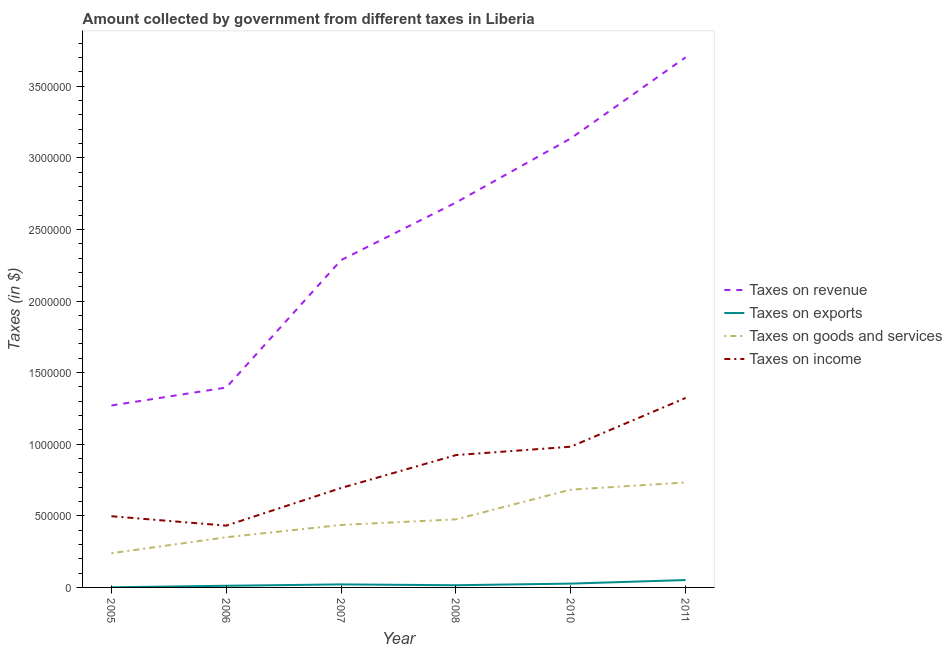What is the amount collected as tax on revenue in 2011?
Offer a terse response. 3.70e+06. Across all years, what is the maximum amount collected as tax on revenue?
Make the answer very short. 3.70e+06. Across all years, what is the minimum amount collected as tax on exports?
Your answer should be very brief. 822.63. What is the total amount collected as tax on income in the graph?
Offer a terse response. 4.85e+06. What is the difference between the amount collected as tax on income in 2007 and that in 2010?
Your answer should be compact. -2.88e+05. What is the difference between the amount collected as tax on exports in 2011 and the amount collected as tax on income in 2008?
Provide a short and direct response. -8.73e+05. What is the average amount collected as tax on revenue per year?
Your response must be concise. 2.41e+06. In the year 2008, what is the difference between the amount collected as tax on income and amount collected as tax on revenue?
Ensure brevity in your answer.  -1.76e+06. In how many years, is the amount collected as tax on goods greater than 2000000 $?
Offer a very short reply. 0. What is the ratio of the amount collected as tax on income in 2005 to that in 2008?
Give a very brief answer. 0.54. Is the amount collected as tax on exports in 2006 less than that in 2008?
Give a very brief answer. Yes. What is the difference between the highest and the second highest amount collected as tax on income?
Keep it short and to the point. 3.41e+05. What is the difference between the highest and the lowest amount collected as tax on income?
Provide a short and direct response. 8.92e+05. In how many years, is the amount collected as tax on exports greater than the average amount collected as tax on exports taken over all years?
Your answer should be compact. 2. Is it the case that in every year, the sum of the amount collected as tax on goods and amount collected as tax on income is greater than the sum of amount collected as tax on exports and amount collected as tax on revenue?
Offer a very short reply. No. Is it the case that in every year, the sum of the amount collected as tax on revenue and amount collected as tax on exports is greater than the amount collected as tax on goods?
Your answer should be compact. Yes. How many years are there in the graph?
Your answer should be compact. 6. What is the difference between two consecutive major ticks on the Y-axis?
Your answer should be compact. 5.00e+05. Does the graph contain any zero values?
Offer a very short reply. No. Does the graph contain grids?
Provide a short and direct response. No. Where does the legend appear in the graph?
Make the answer very short. Center right. How many legend labels are there?
Your answer should be very brief. 4. What is the title of the graph?
Make the answer very short. Amount collected by government from different taxes in Liberia. Does "UNHCR" appear as one of the legend labels in the graph?
Make the answer very short. No. What is the label or title of the X-axis?
Make the answer very short. Year. What is the label or title of the Y-axis?
Ensure brevity in your answer.  Taxes (in $). What is the Taxes (in $) in Taxes on revenue in 2005?
Your answer should be compact. 1.27e+06. What is the Taxes (in $) of Taxes on exports in 2005?
Keep it short and to the point. 822.63. What is the Taxes (in $) of Taxes on goods and services in 2005?
Offer a terse response. 2.39e+05. What is the Taxes (in $) of Taxes on income in 2005?
Provide a short and direct response. 4.97e+05. What is the Taxes (in $) in Taxes on revenue in 2006?
Ensure brevity in your answer.  1.40e+06. What is the Taxes (in $) of Taxes on exports in 2006?
Keep it short and to the point. 1.16e+04. What is the Taxes (in $) in Taxes on goods and services in 2006?
Your answer should be very brief. 3.50e+05. What is the Taxes (in $) in Taxes on income in 2006?
Keep it short and to the point. 4.32e+05. What is the Taxes (in $) in Taxes on revenue in 2007?
Your answer should be very brief. 2.29e+06. What is the Taxes (in $) of Taxes on exports in 2007?
Offer a terse response. 2.11e+04. What is the Taxes (in $) of Taxes on goods and services in 2007?
Offer a terse response. 4.36e+05. What is the Taxes (in $) of Taxes on income in 2007?
Provide a short and direct response. 6.94e+05. What is the Taxes (in $) in Taxes on revenue in 2008?
Give a very brief answer. 2.69e+06. What is the Taxes (in $) in Taxes on exports in 2008?
Your response must be concise. 1.54e+04. What is the Taxes (in $) of Taxes on goods and services in 2008?
Provide a short and direct response. 4.75e+05. What is the Taxes (in $) in Taxes on income in 2008?
Keep it short and to the point. 9.24e+05. What is the Taxes (in $) of Taxes on revenue in 2010?
Offer a terse response. 3.14e+06. What is the Taxes (in $) of Taxes on exports in 2010?
Give a very brief answer. 2.67e+04. What is the Taxes (in $) of Taxes on goods and services in 2010?
Offer a very short reply. 6.83e+05. What is the Taxes (in $) in Taxes on income in 2010?
Provide a succinct answer. 9.83e+05. What is the Taxes (in $) of Taxes on revenue in 2011?
Offer a terse response. 3.70e+06. What is the Taxes (in $) of Taxes on exports in 2011?
Provide a short and direct response. 5.15e+04. What is the Taxes (in $) in Taxes on goods and services in 2011?
Your answer should be very brief. 7.33e+05. What is the Taxes (in $) of Taxes on income in 2011?
Ensure brevity in your answer.  1.32e+06. Across all years, what is the maximum Taxes (in $) of Taxes on revenue?
Your answer should be compact. 3.70e+06. Across all years, what is the maximum Taxes (in $) of Taxes on exports?
Offer a very short reply. 5.15e+04. Across all years, what is the maximum Taxes (in $) of Taxes on goods and services?
Your answer should be very brief. 7.33e+05. Across all years, what is the maximum Taxes (in $) of Taxes on income?
Your answer should be very brief. 1.32e+06. Across all years, what is the minimum Taxes (in $) in Taxes on revenue?
Offer a terse response. 1.27e+06. Across all years, what is the minimum Taxes (in $) in Taxes on exports?
Provide a succinct answer. 822.63. Across all years, what is the minimum Taxes (in $) in Taxes on goods and services?
Ensure brevity in your answer.  2.39e+05. Across all years, what is the minimum Taxes (in $) of Taxes on income?
Offer a terse response. 4.32e+05. What is the total Taxes (in $) in Taxes on revenue in the graph?
Your answer should be very brief. 1.45e+07. What is the total Taxes (in $) of Taxes on exports in the graph?
Offer a very short reply. 1.27e+05. What is the total Taxes (in $) of Taxes on goods and services in the graph?
Your response must be concise. 2.92e+06. What is the total Taxes (in $) in Taxes on income in the graph?
Your answer should be very brief. 4.85e+06. What is the difference between the Taxes (in $) of Taxes on revenue in 2005 and that in 2006?
Ensure brevity in your answer.  -1.25e+05. What is the difference between the Taxes (in $) in Taxes on exports in 2005 and that in 2006?
Your answer should be very brief. -1.08e+04. What is the difference between the Taxes (in $) in Taxes on goods and services in 2005 and that in 2006?
Your answer should be compact. -1.11e+05. What is the difference between the Taxes (in $) in Taxes on income in 2005 and that in 2006?
Offer a terse response. 6.55e+04. What is the difference between the Taxes (in $) in Taxes on revenue in 2005 and that in 2007?
Your answer should be compact. -1.02e+06. What is the difference between the Taxes (in $) in Taxes on exports in 2005 and that in 2007?
Ensure brevity in your answer.  -2.03e+04. What is the difference between the Taxes (in $) in Taxes on goods and services in 2005 and that in 2007?
Keep it short and to the point. -1.97e+05. What is the difference between the Taxes (in $) of Taxes on income in 2005 and that in 2007?
Give a very brief answer. -1.97e+05. What is the difference between the Taxes (in $) in Taxes on revenue in 2005 and that in 2008?
Your response must be concise. -1.42e+06. What is the difference between the Taxes (in $) of Taxes on exports in 2005 and that in 2008?
Your answer should be compact. -1.45e+04. What is the difference between the Taxes (in $) of Taxes on goods and services in 2005 and that in 2008?
Ensure brevity in your answer.  -2.36e+05. What is the difference between the Taxes (in $) in Taxes on income in 2005 and that in 2008?
Your response must be concise. -4.27e+05. What is the difference between the Taxes (in $) in Taxes on revenue in 2005 and that in 2010?
Your response must be concise. -1.87e+06. What is the difference between the Taxes (in $) of Taxes on exports in 2005 and that in 2010?
Provide a short and direct response. -2.58e+04. What is the difference between the Taxes (in $) in Taxes on goods and services in 2005 and that in 2010?
Give a very brief answer. -4.44e+05. What is the difference between the Taxes (in $) of Taxes on income in 2005 and that in 2010?
Offer a terse response. -4.86e+05. What is the difference between the Taxes (in $) of Taxes on revenue in 2005 and that in 2011?
Keep it short and to the point. -2.43e+06. What is the difference between the Taxes (in $) in Taxes on exports in 2005 and that in 2011?
Offer a very short reply. -5.07e+04. What is the difference between the Taxes (in $) in Taxes on goods and services in 2005 and that in 2011?
Offer a very short reply. -4.94e+05. What is the difference between the Taxes (in $) in Taxes on income in 2005 and that in 2011?
Ensure brevity in your answer.  -8.26e+05. What is the difference between the Taxes (in $) of Taxes on revenue in 2006 and that in 2007?
Offer a terse response. -8.90e+05. What is the difference between the Taxes (in $) in Taxes on exports in 2006 and that in 2007?
Offer a very short reply. -9442.48. What is the difference between the Taxes (in $) of Taxes on goods and services in 2006 and that in 2007?
Ensure brevity in your answer.  -8.60e+04. What is the difference between the Taxes (in $) of Taxes on income in 2006 and that in 2007?
Give a very brief answer. -2.63e+05. What is the difference between the Taxes (in $) of Taxes on revenue in 2006 and that in 2008?
Make the answer very short. -1.29e+06. What is the difference between the Taxes (in $) of Taxes on exports in 2006 and that in 2008?
Give a very brief answer. -3711.06. What is the difference between the Taxes (in $) of Taxes on goods and services in 2006 and that in 2008?
Ensure brevity in your answer.  -1.25e+05. What is the difference between the Taxes (in $) in Taxes on income in 2006 and that in 2008?
Offer a terse response. -4.93e+05. What is the difference between the Taxes (in $) in Taxes on revenue in 2006 and that in 2010?
Provide a succinct answer. -1.74e+06. What is the difference between the Taxes (in $) of Taxes on exports in 2006 and that in 2010?
Offer a very short reply. -1.50e+04. What is the difference between the Taxes (in $) of Taxes on goods and services in 2006 and that in 2010?
Your answer should be very brief. -3.32e+05. What is the difference between the Taxes (in $) in Taxes on income in 2006 and that in 2010?
Ensure brevity in your answer.  -5.51e+05. What is the difference between the Taxes (in $) of Taxes on revenue in 2006 and that in 2011?
Provide a succinct answer. -2.31e+06. What is the difference between the Taxes (in $) in Taxes on exports in 2006 and that in 2011?
Offer a very short reply. -3.99e+04. What is the difference between the Taxes (in $) of Taxes on goods and services in 2006 and that in 2011?
Provide a succinct answer. -3.83e+05. What is the difference between the Taxes (in $) of Taxes on income in 2006 and that in 2011?
Your answer should be very brief. -8.92e+05. What is the difference between the Taxes (in $) of Taxes on revenue in 2007 and that in 2008?
Give a very brief answer. -4.02e+05. What is the difference between the Taxes (in $) of Taxes on exports in 2007 and that in 2008?
Offer a terse response. 5731.42. What is the difference between the Taxes (in $) of Taxes on goods and services in 2007 and that in 2008?
Make the answer very short. -3.91e+04. What is the difference between the Taxes (in $) of Taxes on income in 2007 and that in 2008?
Your response must be concise. -2.30e+05. What is the difference between the Taxes (in $) of Taxes on revenue in 2007 and that in 2010?
Ensure brevity in your answer.  -8.50e+05. What is the difference between the Taxes (in $) in Taxes on exports in 2007 and that in 2010?
Keep it short and to the point. -5566.22. What is the difference between the Taxes (in $) in Taxes on goods and services in 2007 and that in 2010?
Your response must be concise. -2.46e+05. What is the difference between the Taxes (in $) in Taxes on income in 2007 and that in 2010?
Make the answer very short. -2.88e+05. What is the difference between the Taxes (in $) of Taxes on revenue in 2007 and that in 2011?
Offer a terse response. -1.42e+06. What is the difference between the Taxes (in $) of Taxes on exports in 2007 and that in 2011?
Keep it short and to the point. -3.05e+04. What is the difference between the Taxes (in $) of Taxes on goods and services in 2007 and that in 2011?
Provide a short and direct response. -2.97e+05. What is the difference between the Taxes (in $) of Taxes on income in 2007 and that in 2011?
Your answer should be very brief. -6.29e+05. What is the difference between the Taxes (in $) of Taxes on revenue in 2008 and that in 2010?
Your answer should be compact. -4.48e+05. What is the difference between the Taxes (in $) of Taxes on exports in 2008 and that in 2010?
Ensure brevity in your answer.  -1.13e+04. What is the difference between the Taxes (in $) of Taxes on goods and services in 2008 and that in 2010?
Keep it short and to the point. -2.07e+05. What is the difference between the Taxes (in $) in Taxes on income in 2008 and that in 2010?
Offer a terse response. -5.85e+04. What is the difference between the Taxes (in $) of Taxes on revenue in 2008 and that in 2011?
Provide a short and direct response. -1.01e+06. What is the difference between the Taxes (in $) in Taxes on exports in 2008 and that in 2011?
Offer a terse response. -3.62e+04. What is the difference between the Taxes (in $) in Taxes on goods and services in 2008 and that in 2011?
Make the answer very short. -2.58e+05. What is the difference between the Taxes (in $) in Taxes on income in 2008 and that in 2011?
Offer a very short reply. -3.99e+05. What is the difference between the Taxes (in $) of Taxes on revenue in 2010 and that in 2011?
Provide a short and direct response. -5.66e+05. What is the difference between the Taxes (in $) of Taxes on exports in 2010 and that in 2011?
Provide a succinct answer. -2.49e+04. What is the difference between the Taxes (in $) of Taxes on goods and services in 2010 and that in 2011?
Your response must be concise. -5.03e+04. What is the difference between the Taxes (in $) of Taxes on income in 2010 and that in 2011?
Offer a terse response. -3.41e+05. What is the difference between the Taxes (in $) in Taxes on revenue in 2005 and the Taxes (in $) in Taxes on exports in 2006?
Provide a succinct answer. 1.26e+06. What is the difference between the Taxes (in $) in Taxes on revenue in 2005 and the Taxes (in $) in Taxes on goods and services in 2006?
Provide a short and direct response. 9.20e+05. What is the difference between the Taxes (in $) of Taxes on revenue in 2005 and the Taxes (in $) of Taxes on income in 2006?
Your response must be concise. 8.39e+05. What is the difference between the Taxes (in $) of Taxes on exports in 2005 and the Taxes (in $) of Taxes on goods and services in 2006?
Provide a succinct answer. -3.49e+05. What is the difference between the Taxes (in $) of Taxes on exports in 2005 and the Taxes (in $) of Taxes on income in 2006?
Your answer should be compact. -4.31e+05. What is the difference between the Taxes (in $) of Taxes on goods and services in 2005 and the Taxes (in $) of Taxes on income in 2006?
Provide a short and direct response. -1.92e+05. What is the difference between the Taxes (in $) in Taxes on revenue in 2005 and the Taxes (in $) in Taxes on exports in 2007?
Provide a short and direct response. 1.25e+06. What is the difference between the Taxes (in $) of Taxes on revenue in 2005 and the Taxes (in $) of Taxes on goods and services in 2007?
Provide a short and direct response. 8.34e+05. What is the difference between the Taxes (in $) of Taxes on revenue in 2005 and the Taxes (in $) of Taxes on income in 2007?
Give a very brief answer. 5.76e+05. What is the difference between the Taxes (in $) of Taxes on exports in 2005 and the Taxes (in $) of Taxes on goods and services in 2007?
Keep it short and to the point. -4.35e+05. What is the difference between the Taxes (in $) of Taxes on exports in 2005 and the Taxes (in $) of Taxes on income in 2007?
Keep it short and to the point. -6.93e+05. What is the difference between the Taxes (in $) of Taxes on goods and services in 2005 and the Taxes (in $) of Taxes on income in 2007?
Give a very brief answer. -4.55e+05. What is the difference between the Taxes (in $) of Taxes on revenue in 2005 and the Taxes (in $) of Taxes on exports in 2008?
Make the answer very short. 1.25e+06. What is the difference between the Taxes (in $) of Taxes on revenue in 2005 and the Taxes (in $) of Taxes on goods and services in 2008?
Make the answer very short. 7.95e+05. What is the difference between the Taxes (in $) in Taxes on revenue in 2005 and the Taxes (in $) in Taxes on income in 2008?
Your response must be concise. 3.46e+05. What is the difference between the Taxes (in $) of Taxes on exports in 2005 and the Taxes (in $) of Taxes on goods and services in 2008?
Make the answer very short. -4.75e+05. What is the difference between the Taxes (in $) of Taxes on exports in 2005 and the Taxes (in $) of Taxes on income in 2008?
Your response must be concise. -9.23e+05. What is the difference between the Taxes (in $) in Taxes on goods and services in 2005 and the Taxes (in $) in Taxes on income in 2008?
Give a very brief answer. -6.85e+05. What is the difference between the Taxes (in $) in Taxes on revenue in 2005 and the Taxes (in $) in Taxes on exports in 2010?
Give a very brief answer. 1.24e+06. What is the difference between the Taxes (in $) of Taxes on revenue in 2005 and the Taxes (in $) of Taxes on goods and services in 2010?
Provide a succinct answer. 5.88e+05. What is the difference between the Taxes (in $) of Taxes on revenue in 2005 and the Taxes (in $) of Taxes on income in 2010?
Offer a very short reply. 2.88e+05. What is the difference between the Taxes (in $) of Taxes on exports in 2005 and the Taxes (in $) of Taxes on goods and services in 2010?
Provide a succinct answer. -6.82e+05. What is the difference between the Taxes (in $) in Taxes on exports in 2005 and the Taxes (in $) in Taxes on income in 2010?
Your answer should be very brief. -9.82e+05. What is the difference between the Taxes (in $) of Taxes on goods and services in 2005 and the Taxes (in $) of Taxes on income in 2010?
Offer a very short reply. -7.43e+05. What is the difference between the Taxes (in $) of Taxes on revenue in 2005 and the Taxes (in $) of Taxes on exports in 2011?
Your response must be concise. 1.22e+06. What is the difference between the Taxes (in $) in Taxes on revenue in 2005 and the Taxes (in $) in Taxes on goods and services in 2011?
Keep it short and to the point. 5.37e+05. What is the difference between the Taxes (in $) in Taxes on revenue in 2005 and the Taxes (in $) in Taxes on income in 2011?
Give a very brief answer. -5.28e+04. What is the difference between the Taxes (in $) of Taxes on exports in 2005 and the Taxes (in $) of Taxes on goods and services in 2011?
Your response must be concise. -7.32e+05. What is the difference between the Taxes (in $) of Taxes on exports in 2005 and the Taxes (in $) of Taxes on income in 2011?
Keep it short and to the point. -1.32e+06. What is the difference between the Taxes (in $) in Taxes on goods and services in 2005 and the Taxes (in $) in Taxes on income in 2011?
Provide a succinct answer. -1.08e+06. What is the difference between the Taxes (in $) of Taxes on revenue in 2006 and the Taxes (in $) of Taxes on exports in 2007?
Provide a short and direct response. 1.37e+06. What is the difference between the Taxes (in $) of Taxes on revenue in 2006 and the Taxes (in $) of Taxes on goods and services in 2007?
Make the answer very short. 9.60e+05. What is the difference between the Taxes (in $) in Taxes on revenue in 2006 and the Taxes (in $) in Taxes on income in 2007?
Offer a terse response. 7.01e+05. What is the difference between the Taxes (in $) in Taxes on exports in 2006 and the Taxes (in $) in Taxes on goods and services in 2007?
Provide a short and direct response. -4.25e+05. What is the difference between the Taxes (in $) in Taxes on exports in 2006 and the Taxes (in $) in Taxes on income in 2007?
Your answer should be very brief. -6.83e+05. What is the difference between the Taxes (in $) in Taxes on goods and services in 2006 and the Taxes (in $) in Taxes on income in 2007?
Provide a short and direct response. -3.44e+05. What is the difference between the Taxes (in $) of Taxes on revenue in 2006 and the Taxes (in $) of Taxes on exports in 2008?
Keep it short and to the point. 1.38e+06. What is the difference between the Taxes (in $) in Taxes on revenue in 2006 and the Taxes (in $) in Taxes on goods and services in 2008?
Your answer should be compact. 9.20e+05. What is the difference between the Taxes (in $) of Taxes on revenue in 2006 and the Taxes (in $) of Taxes on income in 2008?
Keep it short and to the point. 4.72e+05. What is the difference between the Taxes (in $) in Taxes on exports in 2006 and the Taxes (in $) in Taxes on goods and services in 2008?
Provide a succinct answer. -4.64e+05. What is the difference between the Taxes (in $) in Taxes on exports in 2006 and the Taxes (in $) in Taxes on income in 2008?
Your answer should be compact. -9.12e+05. What is the difference between the Taxes (in $) of Taxes on goods and services in 2006 and the Taxes (in $) of Taxes on income in 2008?
Your answer should be very brief. -5.74e+05. What is the difference between the Taxes (in $) in Taxes on revenue in 2006 and the Taxes (in $) in Taxes on exports in 2010?
Ensure brevity in your answer.  1.37e+06. What is the difference between the Taxes (in $) in Taxes on revenue in 2006 and the Taxes (in $) in Taxes on goods and services in 2010?
Offer a terse response. 7.13e+05. What is the difference between the Taxes (in $) of Taxes on revenue in 2006 and the Taxes (in $) of Taxes on income in 2010?
Your answer should be very brief. 4.13e+05. What is the difference between the Taxes (in $) in Taxes on exports in 2006 and the Taxes (in $) in Taxes on goods and services in 2010?
Make the answer very short. -6.71e+05. What is the difference between the Taxes (in $) in Taxes on exports in 2006 and the Taxes (in $) in Taxes on income in 2010?
Provide a succinct answer. -9.71e+05. What is the difference between the Taxes (in $) of Taxes on goods and services in 2006 and the Taxes (in $) of Taxes on income in 2010?
Offer a very short reply. -6.32e+05. What is the difference between the Taxes (in $) in Taxes on revenue in 2006 and the Taxes (in $) in Taxes on exports in 2011?
Give a very brief answer. 1.34e+06. What is the difference between the Taxes (in $) in Taxes on revenue in 2006 and the Taxes (in $) in Taxes on goods and services in 2011?
Your response must be concise. 6.63e+05. What is the difference between the Taxes (in $) in Taxes on revenue in 2006 and the Taxes (in $) in Taxes on income in 2011?
Your answer should be very brief. 7.27e+04. What is the difference between the Taxes (in $) in Taxes on exports in 2006 and the Taxes (in $) in Taxes on goods and services in 2011?
Your response must be concise. -7.21e+05. What is the difference between the Taxes (in $) in Taxes on exports in 2006 and the Taxes (in $) in Taxes on income in 2011?
Provide a succinct answer. -1.31e+06. What is the difference between the Taxes (in $) of Taxes on goods and services in 2006 and the Taxes (in $) of Taxes on income in 2011?
Keep it short and to the point. -9.73e+05. What is the difference between the Taxes (in $) in Taxes on revenue in 2007 and the Taxes (in $) in Taxes on exports in 2008?
Offer a very short reply. 2.27e+06. What is the difference between the Taxes (in $) of Taxes on revenue in 2007 and the Taxes (in $) of Taxes on goods and services in 2008?
Offer a very short reply. 1.81e+06. What is the difference between the Taxes (in $) in Taxes on revenue in 2007 and the Taxes (in $) in Taxes on income in 2008?
Provide a short and direct response. 1.36e+06. What is the difference between the Taxes (in $) in Taxes on exports in 2007 and the Taxes (in $) in Taxes on goods and services in 2008?
Your response must be concise. -4.54e+05. What is the difference between the Taxes (in $) of Taxes on exports in 2007 and the Taxes (in $) of Taxes on income in 2008?
Ensure brevity in your answer.  -9.03e+05. What is the difference between the Taxes (in $) of Taxes on goods and services in 2007 and the Taxes (in $) of Taxes on income in 2008?
Your answer should be very brief. -4.88e+05. What is the difference between the Taxes (in $) in Taxes on revenue in 2007 and the Taxes (in $) in Taxes on exports in 2010?
Make the answer very short. 2.26e+06. What is the difference between the Taxes (in $) in Taxes on revenue in 2007 and the Taxes (in $) in Taxes on goods and services in 2010?
Your answer should be compact. 1.60e+06. What is the difference between the Taxes (in $) of Taxes on revenue in 2007 and the Taxes (in $) of Taxes on income in 2010?
Ensure brevity in your answer.  1.30e+06. What is the difference between the Taxes (in $) of Taxes on exports in 2007 and the Taxes (in $) of Taxes on goods and services in 2010?
Keep it short and to the point. -6.62e+05. What is the difference between the Taxes (in $) in Taxes on exports in 2007 and the Taxes (in $) in Taxes on income in 2010?
Make the answer very short. -9.62e+05. What is the difference between the Taxes (in $) of Taxes on goods and services in 2007 and the Taxes (in $) of Taxes on income in 2010?
Provide a succinct answer. -5.46e+05. What is the difference between the Taxes (in $) in Taxes on revenue in 2007 and the Taxes (in $) in Taxes on exports in 2011?
Provide a short and direct response. 2.23e+06. What is the difference between the Taxes (in $) of Taxes on revenue in 2007 and the Taxes (in $) of Taxes on goods and services in 2011?
Keep it short and to the point. 1.55e+06. What is the difference between the Taxes (in $) in Taxes on revenue in 2007 and the Taxes (in $) in Taxes on income in 2011?
Your answer should be compact. 9.63e+05. What is the difference between the Taxes (in $) of Taxes on exports in 2007 and the Taxes (in $) of Taxes on goods and services in 2011?
Your answer should be very brief. -7.12e+05. What is the difference between the Taxes (in $) of Taxes on exports in 2007 and the Taxes (in $) of Taxes on income in 2011?
Make the answer very short. -1.30e+06. What is the difference between the Taxes (in $) of Taxes on goods and services in 2007 and the Taxes (in $) of Taxes on income in 2011?
Provide a short and direct response. -8.87e+05. What is the difference between the Taxes (in $) of Taxes on revenue in 2008 and the Taxes (in $) of Taxes on exports in 2010?
Provide a succinct answer. 2.66e+06. What is the difference between the Taxes (in $) in Taxes on revenue in 2008 and the Taxes (in $) in Taxes on goods and services in 2010?
Make the answer very short. 2.00e+06. What is the difference between the Taxes (in $) of Taxes on revenue in 2008 and the Taxes (in $) of Taxes on income in 2010?
Provide a short and direct response. 1.70e+06. What is the difference between the Taxes (in $) of Taxes on exports in 2008 and the Taxes (in $) of Taxes on goods and services in 2010?
Ensure brevity in your answer.  -6.67e+05. What is the difference between the Taxes (in $) of Taxes on exports in 2008 and the Taxes (in $) of Taxes on income in 2010?
Offer a terse response. -9.67e+05. What is the difference between the Taxes (in $) in Taxes on goods and services in 2008 and the Taxes (in $) in Taxes on income in 2010?
Provide a succinct answer. -5.07e+05. What is the difference between the Taxes (in $) in Taxes on revenue in 2008 and the Taxes (in $) in Taxes on exports in 2011?
Offer a very short reply. 2.64e+06. What is the difference between the Taxes (in $) in Taxes on revenue in 2008 and the Taxes (in $) in Taxes on goods and services in 2011?
Your answer should be compact. 1.95e+06. What is the difference between the Taxes (in $) of Taxes on revenue in 2008 and the Taxes (in $) of Taxes on income in 2011?
Provide a short and direct response. 1.36e+06. What is the difference between the Taxes (in $) of Taxes on exports in 2008 and the Taxes (in $) of Taxes on goods and services in 2011?
Offer a terse response. -7.18e+05. What is the difference between the Taxes (in $) in Taxes on exports in 2008 and the Taxes (in $) in Taxes on income in 2011?
Your response must be concise. -1.31e+06. What is the difference between the Taxes (in $) of Taxes on goods and services in 2008 and the Taxes (in $) of Taxes on income in 2011?
Keep it short and to the point. -8.48e+05. What is the difference between the Taxes (in $) in Taxes on revenue in 2010 and the Taxes (in $) in Taxes on exports in 2011?
Keep it short and to the point. 3.08e+06. What is the difference between the Taxes (in $) of Taxes on revenue in 2010 and the Taxes (in $) of Taxes on goods and services in 2011?
Provide a succinct answer. 2.40e+06. What is the difference between the Taxes (in $) in Taxes on revenue in 2010 and the Taxes (in $) in Taxes on income in 2011?
Give a very brief answer. 1.81e+06. What is the difference between the Taxes (in $) of Taxes on exports in 2010 and the Taxes (in $) of Taxes on goods and services in 2011?
Make the answer very short. -7.06e+05. What is the difference between the Taxes (in $) in Taxes on exports in 2010 and the Taxes (in $) in Taxes on income in 2011?
Offer a very short reply. -1.30e+06. What is the difference between the Taxes (in $) of Taxes on goods and services in 2010 and the Taxes (in $) of Taxes on income in 2011?
Offer a terse response. -6.40e+05. What is the average Taxes (in $) in Taxes on revenue per year?
Ensure brevity in your answer.  2.41e+06. What is the average Taxes (in $) in Taxes on exports per year?
Provide a short and direct response. 2.12e+04. What is the average Taxes (in $) in Taxes on goods and services per year?
Keep it short and to the point. 4.86e+05. What is the average Taxes (in $) of Taxes on income per year?
Make the answer very short. 8.09e+05. In the year 2005, what is the difference between the Taxes (in $) of Taxes on revenue and Taxes (in $) of Taxes on exports?
Make the answer very short. 1.27e+06. In the year 2005, what is the difference between the Taxes (in $) of Taxes on revenue and Taxes (in $) of Taxes on goods and services?
Make the answer very short. 1.03e+06. In the year 2005, what is the difference between the Taxes (in $) of Taxes on revenue and Taxes (in $) of Taxes on income?
Your answer should be very brief. 7.73e+05. In the year 2005, what is the difference between the Taxes (in $) of Taxes on exports and Taxes (in $) of Taxes on goods and services?
Give a very brief answer. -2.38e+05. In the year 2005, what is the difference between the Taxes (in $) in Taxes on exports and Taxes (in $) in Taxes on income?
Keep it short and to the point. -4.96e+05. In the year 2005, what is the difference between the Taxes (in $) in Taxes on goods and services and Taxes (in $) in Taxes on income?
Offer a very short reply. -2.58e+05. In the year 2006, what is the difference between the Taxes (in $) in Taxes on revenue and Taxes (in $) in Taxes on exports?
Offer a very short reply. 1.38e+06. In the year 2006, what is the difference between the Taxes (in $) in Taxes on revenue and Taxes (in $) in Taxes on goods and services?
Offer a terse response. 1.05e+06. In the year 2006, what is the difference between the Taxes (in $) in Taxes on revenue and Taxes (in $) in Taxes on income?
Provide a short and direct response. 9.64e+05. In the year 2006, what is the difference between the Taxes (in $) of Taxes on exports and Taxes (in $) of Taxes on goods and services?
Your answer should be very brief. -3.39e+05. In the year 2006, what is the difference between the Taxes (in $) in Taxes on exports and Taxes (in $) in Taxes on income?
Make the answer very short. -4.20e+05. In the year 2006, what is the difference between the Taxes (in $) of Taxes on goods and services and Taxes (in $) of Taxes on income?
Offer a very short reply. -8.13e+04. In the year 2007, what is the difference between the Taxes (in $) of Taxes on revenue and Taxes (in $) of Taxes on exports?
Make the answer very short. 2.26e+06. In the year 2007, what is the difference between the Taxes (in $) in Taxes on revenue and Taxes (in $) in Taxes on goods and services?
Your answer should be compact. 1.85e+06. In the year 2007, what is the difference between the Taxes (in $) of Taxes on revenue and Taxes (in $) of Taxes on income?
Provide a short and direct response. 1.59e+06. In the year 2007, what is the difference between the Taxes (in $) in Taxes on exports and Taxes (in $) in Taxes on goods and services?
Ensure brevity in your answer.  -4.15e+05. In the year 2007, what is the difference between the Taxes (in $) in Taxes on exports and Taxes (in $) in Taxes on income?
Provide a succinct answer. -6.73e+05. In the year 2007, what is the difference between the Taxes (in $) in Taxes on goods and services and Taxes (in $) in Taxes on income?
Provide a short and direct response. -2.58e+05. In the year 2008, what is the difference between the Taxes (in $) in Taxes on revenue and Taxes (in $) in Taxes on exports?
Make the answer very short. 2.67e+06. In the year 2008, what is the difference between the Taxes (in $) of Taxes on revenue and Taxes (in $) of Taxes on goods and services?
Your answer should be very brief. 2.21e+06. In the year 2008, what is the difference between the Taxes (in $) of Taxes on revenue and Taxes (in $) of Taxes on income?
Your answer should be very brief. 1.76e+06. In the year 2008, what is the difference between the Taxes (in $) of Taxes on exports and Taxes (in $) of Taxes on goods and services?
Your answer should be very brief. -4.60e+05. In the year 2008, what is the difference between the Taxes (in $) in Taxes on exports and Taxes (in $) in Taxes on income?
Offer a terse response. -9.09e+05. In the year 2008, what is the difference between the Taxes (in $) of Taxes on goods and services and Taxes (in $) of Taxes on income?
Provide a short and direct response. -4.49e+05. In the year 2010, what is the difference between the Taxes (in $) in Taxes on revenue and Taxes (in $) in Taxes on exports?
Keep it short and to the point. 3.11e+06. In the year 2010, what is the difference between the Taxes (in $) of Taxes on revenue and Taxes (in $) of Taxes on goods and services?
Provide a short and direct response. 2.45e+06. In the year 2010, what is the difference between the Taxes (in $) in Taxes on revenue and Taxes (in $) in Taxes on income?
Your response must be concise. 2.15e+06. In the year 2010, what is the difference between the Taxes (in $) in Taxes on exports and Taxes (in $) in Taxes on goods and services?
Provide a short and direct response. -6.56e+05. In the year 2010, what is the difference between the Taxes (in $) of Taxes on exports and Taxes (in $) of Taxes on income?
Provide a succinct answer. -9.56e+05. In the year 2010, what is the difference between the Taxes (in $) of Taxes on goods and services and Taxes (in $) of Taxes on income?
Keep it short and to the point. -3.00e+05. In the year 2011, what is the difference between the Taxes (in $) of Taxes on revenue and Taxes (in $) of Taxes on exports?
Your answer should be compact. 3.65e+06. In the year 2011, what is the difference between the Taxes (in $) in Taxes on revenue and Taxes (in $) in Taxes on goods and services?
Make the answer very short. 2.97e+06. In the year 2011, what is the difference between the Taxes (in $) of Taxes on revenue and Taxes (in $) of Taxes on income?
Make the answer very short. 2.38e+06. In the year 2011, what is the difference between the Taxes (in $) in Taxes on exports and Taxes (in $) in Taxes on goods and services?
Ensure brevity in your answer.  -6.81e+05. In the year 2011, what is the difference between the Taxes (in $) of Taxes on exports and Taxes (in $) of Taxes on income?
Offer a very short reply. -1.27e+06. In the year 2011, what is the difference between the Taxes (in $) of Taxes on goods and services and Taxes (in $) of Taxes on income?
Keep it short and to the point. -5.90e+05. What is the ratio of the Taxes (in $) of Taxes on revenue in 2005 to that in 2006?
Provide a succinct answer. 0.91. What is the ratio of the Taxes (in $) in Taxes on exports in 2005 to that in 2006?
Provide a short and direct response. 0.07. What is the ratio of the Taxes (in $) in Taxes on goods and services in 2005 to that in 2006?
Ensure brevity in your answer.  0.68. What is the ratio of the Taxes (in $) of Taxes on income in 2005 to that in 2006?
Offer a terse response. 1.15. What is the ratio of the Taxes (in $) in Taxes on revenue in 2005 to that in 2007?
Provide a short and direct response. 0.56. What is the ratio of the Taxes (in $) of Taxes on exports in 2005 to that in 2007?
Offer a very short reply. 0.04. What is the ratio of the Taxes (in $) of Taxes on goods and services in 2005 to that in 2007?
Keep it short and to the point. 0.55. What is the ratio of the Taxes (in $) in Taxes on income in 2005 to that in 2007?
Offer a very short reply. 0.72. What is the ratio of the Taxes (in $) in Taxes on revenue in 2005 to that in 2008?
Provide a succinct answer. 0.47. What is the ratio of the Taxes (in $) in Taxes on exports in 2005 to that in 2008?
Your response must be concise. 0.05. What is the ratio of the Taxes (in $) of Taxes on goods and services in 2005 to that in 2008?
Give a very brief answer. 0.5. What is the ratio of the Taxes (in $) of Taxes on income in 2005 to that in 2008?
Offer a very short reply. 0.54. What is the ratio of the Taxes (in $) of Taxes on revenue in 2005 to that in 2010?
Keep it short and to the point. 0.41. What is the ratio of the Taxes (in $) of Taxes on exports in 2005 to that in 2010?
Give a very brief answer. 0.03. What is the ratio of the Taxes (in $) in Taxes on goods and services in 2005 to that in 2010?
Offer a terse response. 0.35. What is the ratio of the Taxes (in $) in Taxes on income in 2005 to that in 2010?
Provide a short and direct response. 0.51. What is the ratio of the Taxes (in $) in Taxes on revenue in 2005 to that in 2011?
Offer a very short reply. 0.34. What is the ratio of the Taxes (in $) in Taxes on exports in 2005 to that in 2011?
Provide a succinct answer. 0.02. What is the ratio of the Taxes (in $) in Taxes on goods and services in 2005 to that in 2011?
Provide a succinct answer. 0.33. What is the ratio of the Taxes (in $) in Taxes on income in 2005 to that in 2011?
Offer a terse response. 0.38. What is the ratio of the Taxes (in $) in Taxes on revenue in 2006 to that in 2007?
Your answer should be compact. 0.61. What is the ratio of the Taxes (in $) in Taxes on exports in 2006 to that in 2007?
Ensure brevity in your answer.  0.55. What is the ratio of the Taxes (in $) in Taxes on goods and services in 2006 to that in 2007?
Give a very brief answer. 0.8. What is the ratio of the Taxes (in $) of Taxes on income in 2006 to that in 2007?
Offer a very short reply. 0.62. What is the ratio of the Taxes (in $) of Taxes on revenue in 2006 to that in 2008?
Provide a short and direct response. 0.52. What is the ratio of the Taxes (in $) in Taxes on exports in 2006 to that in 2008?
Offer a very short reply. 0.76. What is the ratio of the Taxes (in $) of Taxes on goods and services in 2006 to that in 2008?
Provide a short and direct response. 0.74. What is the ratio of the Taxes (in $) of Taxes on income in 2006 to that in 2008?
Ensure brevity in your answer.  0.47. What is the ratio of the Taxes (in $) in Taxes on revenue in 2006 to that in 2010?
Offer a very short reply. 0.45. What is the ratio of the Taxes (in $) of Taxes on exports in 2006 to that in 2010?
Give a very brief answer. 0.44. What is the ratio of the Taxes (in $) in Taxes on goods and services in 2006 to that in 2010?
Ensure brevity in your answer.  0.51. What is the ratio of the Taxes (in $) in Taxes on income in 2006 to that in 2010?
Offer a very short reply. 0.44. What is the ratio of the Taxes (in $) of Taxes on revenue in 2006 to that in 2011?
Keep it short and to the point. 0.38. What is the ratio of the Taxes (in $) in Taxes on exports in 2006 to that in 2011?
Your answer should be very brief. 0.23. What is the ratio of the Taxes (in $) of Taxes on goods and services in 2006 to that in 2011?
Make the answer very short. 0.48. What is the ratio of the Taxes (in $) of Taxes on income in 2006 to that in 2011?
Offer a very short reply. 0.33. What is the ratio of the Taxes (in $) of Taxes on revenue in 2007 to that in 2008?
Make the answer very short. 0.85. What is the ratio of the Taxes (in $) of Taxes on exports in 2007 to that in 2008?
Your answer should be compact. 1.37. What is the ratio of the Taxes (in $) of Taxes on goods and services in 2007 to that in 2008?
Ensure brevity in your answer.  0.92. What is the ratio of the Taxes (in $) of Taxes on income in 2007 to that in 2008?
Provide a succinct answer. 0.75. What is the ratio of the Taxes (in $) of Taxes on revenue in 2007 to that in 2010?
Provide a succinct answer. 0.73. What is the ratio of the Taxes (in $) of Taxes on exports in 2007 to that in 2010?
Your answer should be compact. 0.79. What is the ratio of the Taxes (in $) of Taxes on goods and services in 2007 to that in 2010?
Your answer should be compact. 0.64. What is the ratio of the Taxes (in $) of Taxes on income in 2007 to that in 2010?
Your response must be concise. 0.71. What is the ratio of the Taxes (in $) of Taxes on revenue in 2007 to that in 2011?
Your answer should be very brief. 0.62. What is the ratio of the Taxes (in $) in Taxes on exports in 2007 to that in 2011?
Provide a short and direct response. 0.41. What is the ratio of the Taxes (in $) of Taxes on goods and services in 2007 to that in 2011?
Your response must be concise. 0.6. What is the ratio of the Taxes (in $) of Taxes on income in 2007 to that in 2011?
Provide a short and direct response. 0.52. What is the ratio of the Taxes (in $) of Taxes on exports in 2008 to that in 2010?
Ensure brevity in your answer.  0.58. What is the ratio of the Taxes (in $) of Taxes on goods and services in 2008 to that in 2010?
Your answer should be compact. 0.7. What is the ratio of the Taxes (in $) of Taxes on income in 2008 to that in 2010?
Provide a succinct answer. 0.94. What is the ratio of the Taxes (in $) of Taxes on revenue in 2008 to that in 2011?
Ensure brevity in your answer.  0.73. What is the ratio of the Taxes (in $) of Taxes on exports in 2008 to that in 2011?
Keep it short and to the point. 0.3. What is the ratio of the Taxes (in $) of Taxes on goods and services in 2008 to that in 2011?
Give a very brief answer. 0.65. What is the ratio of the Taxes (in $) of Taxes on income in 2008 to that in 2011?
Give a very brief answer. 0.7. What is the ratio of the Taxes (in $) in Taxes on revenue in 2010 to that in 2011?
Your answer should be very brief. 0.85. What is the ratio of the Taxes (in $) in Taxes on exports in 2010 to that in 2011?
Ensure brevity in your answer.  0.52. What is the ratio of the Taxes (in $) in Taxes on goods and services in 2010 to that in 2011?
Provide a succinct answer. 0.93. What is the ratio of the Taxes (in $) of Taxes on income in 2010 to that in 2011?
Your response must be concise. 0.74. What is the difference between the highest and the second highest Taxes (in $) of Taxes on revenue?
Keep it short and to the point. 5.66e+05. What is the difference between the highest and the second highest Taxes (in $) of Taxes on exports?
Provide a succinct answer. 2.49e+04. What is the difference between the highest and the second highest Taxes (in $) in Taxes on goods and services?
Give a very brief answer. 5.03e+04. What is the difference between the highest and the second highest Taxes (in $) of Taxes on income?
Your answer should be very brief. 3.41e+05. What is the difference between the highest and the lowest Taxes (in $) of Taxes on revenue?
Ensure brevity in your answer.  2.43e+06. What is the difference between the highest and the lowest Taxes (in $) in Taxes on exports?
Provide a succinct answer. 5.07e+04. What is the difference between the highest and the lowest Taxes (in $) of Taxes on goods and services?
Ensure brevity in your answer.  4.94e+05. What is the difference between the highest and the lowest Taxes (in $) in Taxes on income?
Make the answer very short. 8.92e+05. 